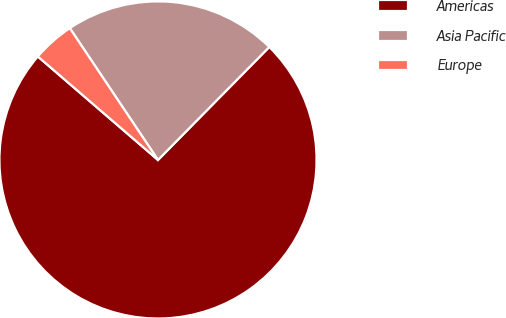<chart> <loc_0><loc_0><loc_500><loc_500><pie_chart><fcel>Americas<fcel>Asia Pacific<fcel>Europe<nl><fcel>73.94%<fcel>21.77%<fcel>4.3%<nl></chart> 